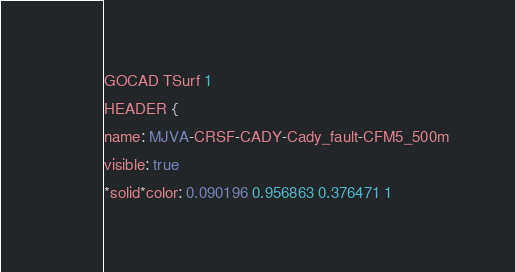<code> <loc_0><loc_0><loc_500><loc_500><_TypeScript_>GOCAD TSurf 1 
HEADER {
name: MJVA-CRSF-CADY-Cady_fault-CFM5_500m
visible: true
*solid*color: 0.090196 0.956863 0.376471 1</code> 